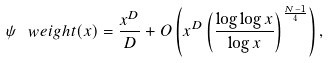<formula> <loc_0><loc_0><loc_500><loc_500>\psi _ { \ } w e i g h t ( x ) = \frac { x ^ { D } } { D } + O \left ( x ^ { D } \left ( \frac { \log \log x } { \log x } \right ) ^ { \frac { N - 1 } 4 } \right ) ,</formula> 